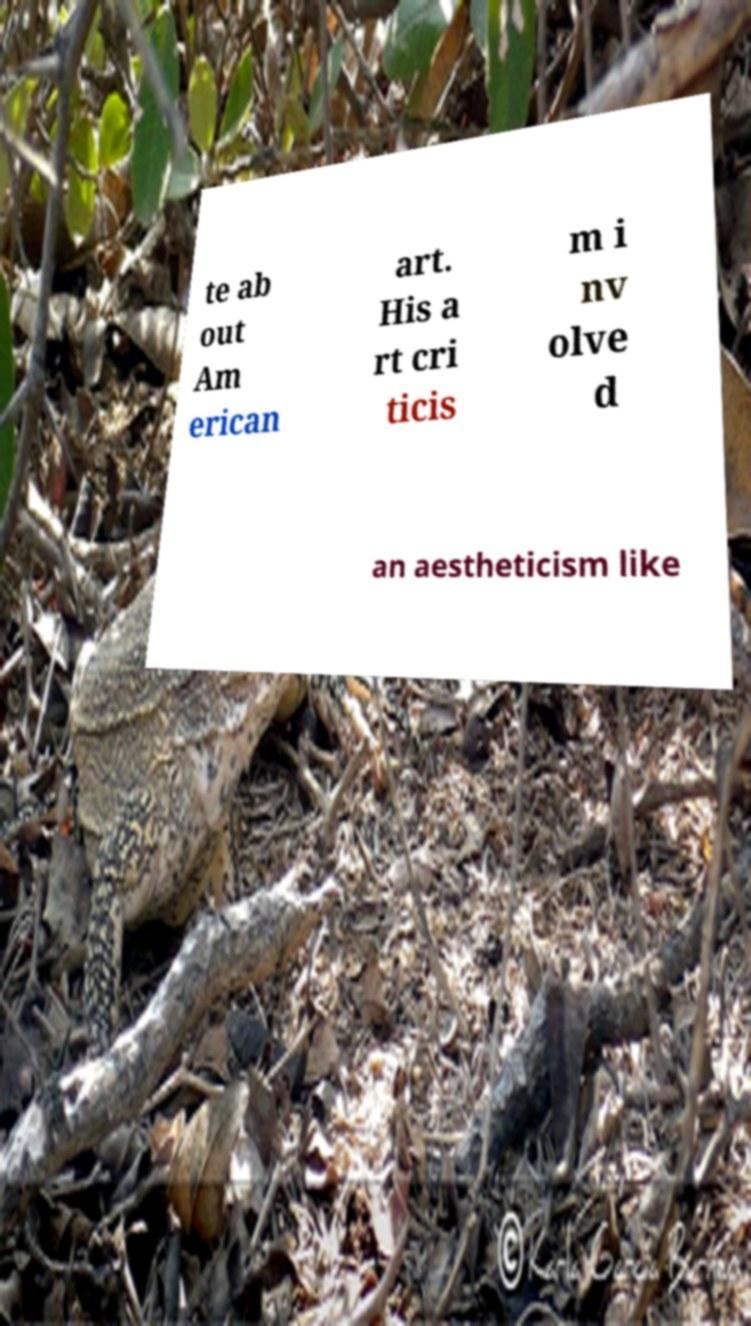Please read and relay the text visible in this image. What does it say? te ab out Am erican art. His a rt cri ticis m i nv olve d an aestheticism like 